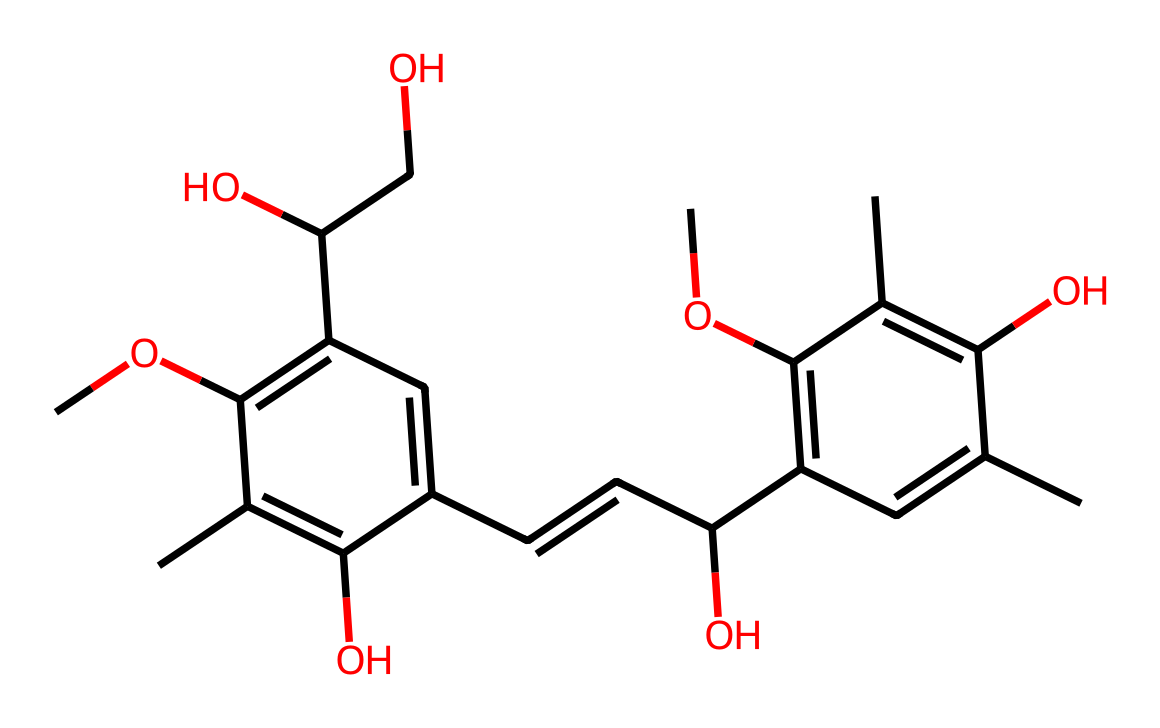What is the total number of carbon atoms in this chemical? By analyzing the SMILES representation, we can count the carbon atoms. Each "C" represents a carbon atom, and from the structure, we count a total of fifteen carbon atoms in the arrangement.
Answer: fifteen How many hydroxyl (–OH) groups are present in this structure? We can identify hydroxyl groups by looking for instances of "O" that are connected to a carbon. In this molecule, there are four instances where oxygen is connected in such a manner, indicating four hydroxyl groups.
Answer: four What type of linkages are present in lignin based on its chemical structure? In the structure of lignin, we see multiple aromatic rings which suggests that it forms ether bonds and carbon-carbon bonds typical of lignin structures. These contribute to the strength and rigidity of the material.
Answer: ether bonds and carbon-carbon bonds What is the molecular property indicated by the number of rings in the structure? The presence of multiple aromatic rings in lignin contributes to its stability and robustness, which is significant for providing structural integrity to tree trunks. The property of being aromatic suggests delocalized electrons, adding to the strength.
Answer: stability Based on the structure, what role does this chemical play in trees? Lignin is critical for providing structural support in plants; it reinforces the cell walls and helps with water transport. The complex structure with multiple rings and linkages supports the sturdiness needed for large trees, contributing to both privacy and shade.
Answer: structural support How many double bonds are present in this compound's structure? To find the number of double bonds, we examine the connections between the carbon atoms in the SMILES. We observe a total of four double bonds between carbon atoms in the structure.
Answer: four 